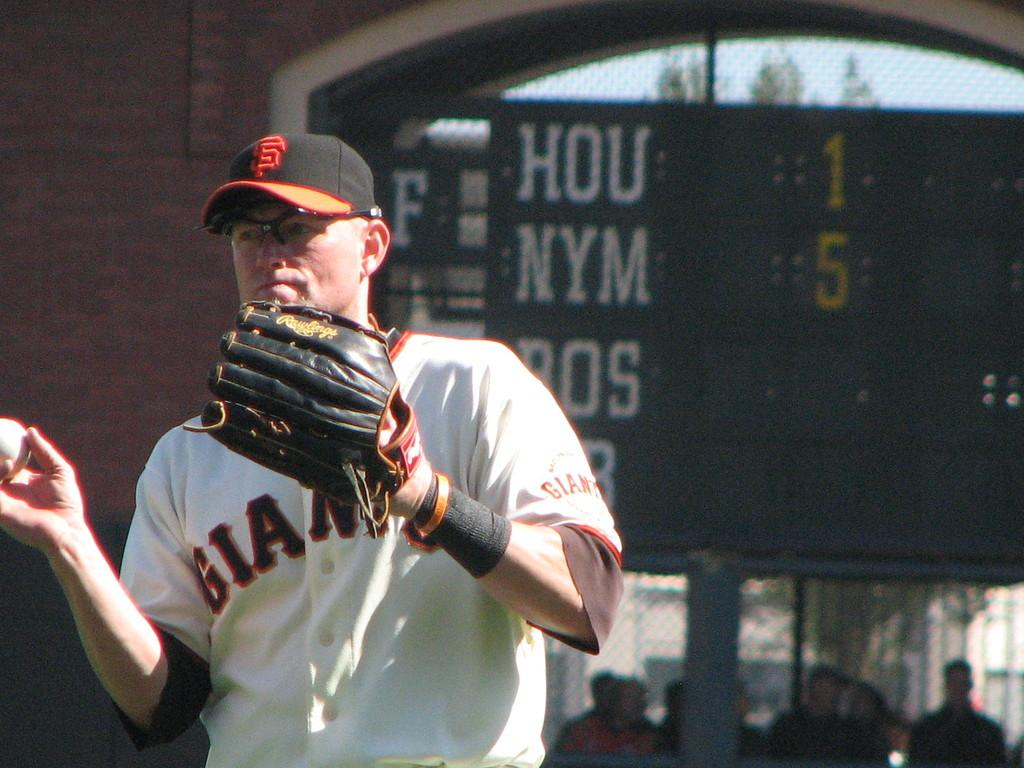<image>
Give a short and clear explanation of the subsequent image. a person wearing a Giants jersey in a stadium 